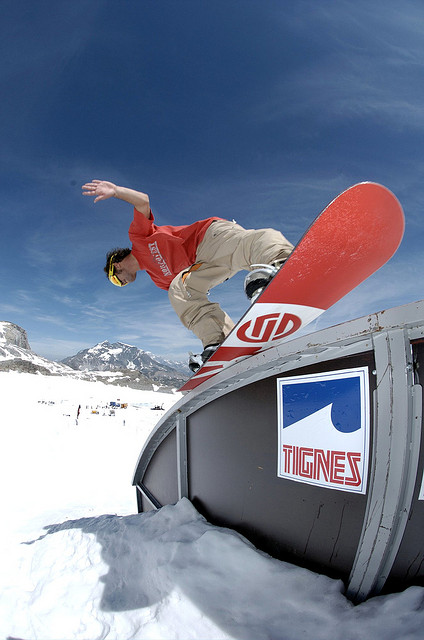Identify and read out the text in this image. TIGNES 